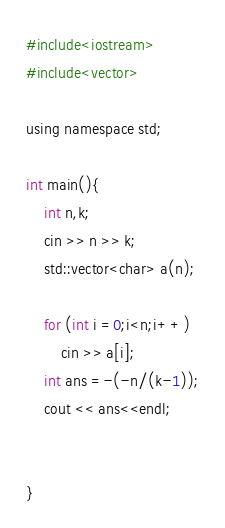<code> <loc_0><loc_0><loc_500><loc_500><_Python_>#include<iostream>
#include<vector>

using namespace std;

int main(){
    int n,k;
    cin >> n >> k;
    std::vector<char> a(n);

    for (int i =0;i<n;i++)
        cin >> a[i];
    int ans =-(-n/(k-1));
    cout << ans<<endl;


}</code> 